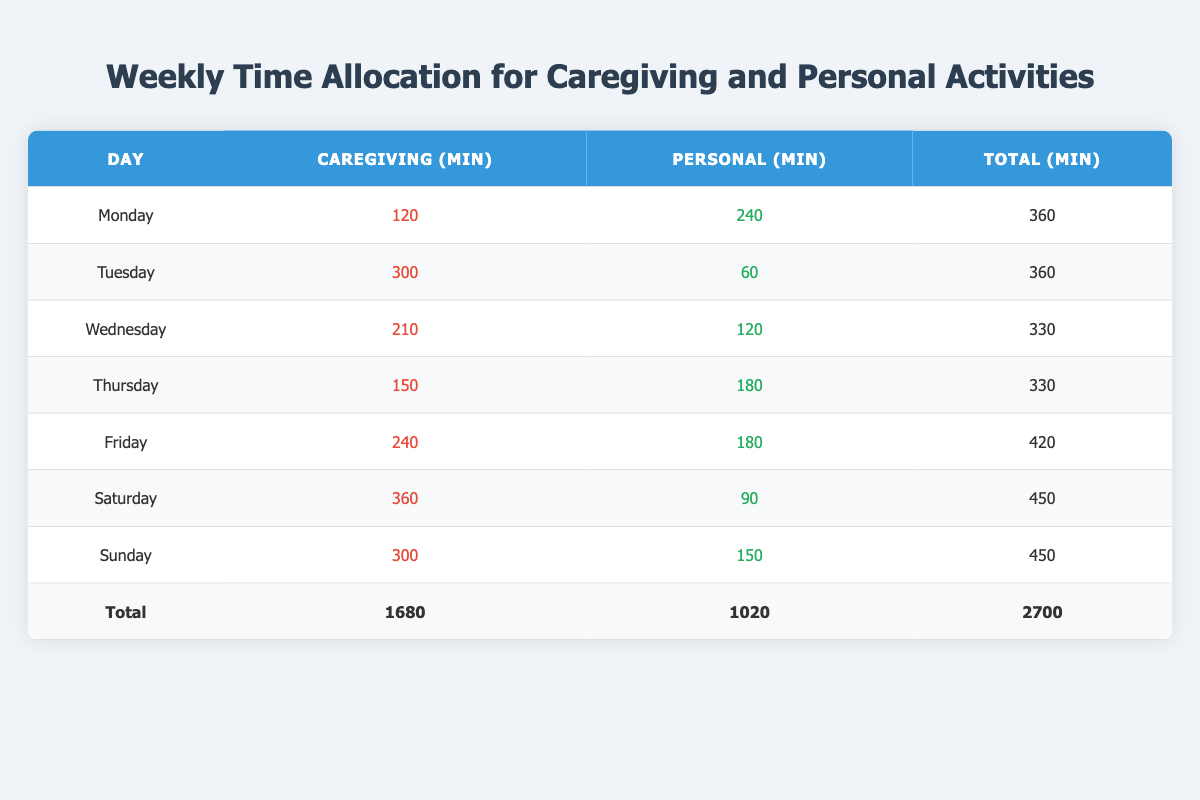What is the total caregiving time allocated on Friday? Referring to the table, the caregiving time for Friday is listed as 240 minutes.
Answer: 240 minutes Which day has the highest allocation of personal time? The highest personal time allocation is on Monday, with 240 minutes.
Answer: Monday Is the total caregiving time across the week more than 1500 minutes? The table shows a total of 1680 minutes for caregiving throughout the week, which is greater than 1500 minutes.
Answer: Yes What is the difference in total minutes between Saturday's caregiving and personal activities? Saturday's caregiving time is 360 minutes and personal time is 90 minutes. The difference is 360 - 90 = 270 minutes.
Answer: 270 minutes On which days are the caregiving and personal time equal? Comparing the caregiving and personal time, no day in the table shows equal values for both (e.g., Monday has 120 caregiving and 240 personal).
Answer: No days are equal What is the average total time allocated for caregiving activities per day? The total caregiving time is 1680 minutes for the week. Divided by 7 days gives an average of 1680 / 7 = 240 minutes per day.
Answer: 240 minutes Which day has the least personal time allocated? Looking at the personal time allocation, Tuesday has the least at 60 minutes.
Answer: Tuesday If we combine the caregiving time from Wednesday and Thursday, how much time do we have? Wednesday's caregiving time is 210 minutes, and Thursday's is 150 minutes. Adding them together, 210 + 150 = 360 minutes.
Answer: 360 minutes What percentage of the total time is dedicated to personal activities? The total time for personal activities is 1020 minutes out of a total of 2700 minutes. The percentage is (1020 / 2700) * 100 ≈ 37.78%.
Answer: Approximately 37.78% 